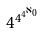<formula> <loc_0><loc_0><loc_500><loc_500>4 ^ { 4 ^ { 4 ^ { \aleph _ { 0 } } } }</formula> 